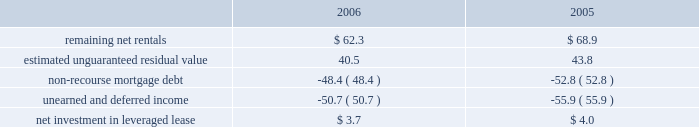Kimco realty corporation and subsidiaries job title kimco realty ar revision 6 serial date / time tuesday , april 03 , 2007 /10:32 pm job number 142704 type current page no .
65 operator pm2 <12345678> at december 31 , 2006 and 2005 , the company 2019s net invest- ment in the leveraged lease consisted of the following ( in mil- lions ) : .
Mortgages and other financing receivables : during january 2006 , the company provided approximately $ 16.0 million as its share of a $ 50.0 million junior participation in a $ 700.0 million first mortgage loan , in connection with a private investment firm 2019s acquisition of a retailer .
This loan participation bore interest at libor plus 7.75% ( 7.75 % ) per annum and had a two-year term with a one-year extension option and was collateralized by certain real estate interests of the retailer .
During june 2006 , the borrower elected to pre-pay the outstanding loan balance of approximately $ 16.0 million in full satisfaction of this loan .
Additionally , during january 2006 , the company provided approximately $ 5.2 million as its share of an $ 11.5 million term loan to a real estate developer for the acquisition of a 59 acre land parcel located in san antonio , tx .
This loan is interest only at a fixed rate of 11.0% ( 11.0 % ) for a term of two years payable monthly and collateralized by a first mortgage on the subject property .
As of december 31 , 2006 , the outstanding balance on this loan was approximately $ 5.2 million .
During february 2006 , the company committed to provide a one year $ 17.2 million credit facility at a fixed rate of 8.0% ( 8.0 % ) for a term of nine months and 9.0% ( 9.0 % ) for the remaining term to a real estate investor for the recapitalization of a discount and entertain- ment mall that it currently owns .
During 2006 , this facility was fully paid and was terminated .
During april 2006 , the company provided two separate mortgages aggregating $ 14.5 million on a property owned by a real estate investor .
Proceeds were used to payoff the existing first mortgage , buyout the existing partner and for redevelopment of the property .
The mortgages bear interest at 8.0% ( 8.0 % ) per annum and mature in 2008 and 2013 .
These mortgages are collateralized by the subject property .
As of december 31 , 2006 , the aggregate outstanding balance on these mortgages was approximately $ 15.0 million , including $ 0.5 million of accrued interest .
During may 2006 , the company provided a cad $ 23.5 million collateralized credit facility at a fixed rate of 8.5% ( 8.5 % ) per annum for a term of two years to a real estate company for the execution of its property acquisitions program .
The credit facility is guaranteed by the real estate company .
The company was issued 9811 units , valued at approximately usd $ 0.1 million , and warrants to purchase up to 0.1 million shares of the real estate company as a loan origination fee .
During august 2006 , the company increased the credit facility to cad $ 45.0 million and received an additional 9811 units , valued at approximately usd $ 0.1 million , and warrants to purchase up to 0.1 million shares of the real estate company .
As of december 31 , 2006 , the outstand- ing balance on this credit facility was approximately cad $ 3.6 million ( approximately usd $ 3.1 million ) .
During september 2005 , a newly formed joint venture , in which the company had an 80% ( 80 % ) interest , acquired a 90% ( 90 % ) interest in a $ 48.4 million mortgage receivable for a purchase price of approximately $ 34.2 million .
This loan bore interest at a rate of three-month libor plus 2.75% ( 2.75 % ) per annum and was scheduled to mature on january 12 , 2010 .
A 626-room hotel located in lake buena vista , fl collateralized the loan .
The company had determined that this joint venture entity was a vie and had further determined that the company was the primary benefici- ary of this vie and had therefore consolidated it for financial reporting purposes .
During march 2006 , the joint venture acquired the remaining 10% ( 10 % ) of this mortgage receivable for a purchase price of approximately $ 3.8 million .
During june 2006 , the joint venture accepted a pre-payment of approximately $ 45.2 million from the borrower as full satisfaction of this loan .
During august 2006 , the company provided $ 8.8 million as its share of a $ 13.2 million 12-month term loan to a retailer for general corporate purposes .
This loan bears interest at a fixed rate of 12.50% ( 12.50 % ) with interest payable monthly and a balloon payment for the principal balance at maturity .
The loan is collateralized by the underlying real estate of the retailer .
Additionally , the company funded $ 13.3 million as its share of a $ 20.0 million revolving debtor-in-possession facility to this retailer .
The facility bears interest at libor plus 3.00% ( 3.00 % ) and has an unused line fee of 0.375% ( 0.375 % ) .
This credit facility is collateralized by a first priority lien on all the retailer 2019s assets .
As of december 31 , 2006 , the compa- ny 2019s share of the outstanding balance on this loan and credit facility was approximately $ 7.6 million and $ 4.9 million , respec- tively .
During september 2006 , the company provided a mxp 57.3 million ( approximately usd $ 5.3 million ) loan to an owner of an operating property in mexico .
The loan , which is collateralized by the property , bears interest at 12.0% ( 12.0 % ) per annum and matures in 2016 .
The company is entitled to a participation feature of 25% ( 25 % ) of annual cash flows after debt service and 20% ( 20 % ) of the gain on sale of the property .
As of december 31 , 2006 , the outstand- ing balance on this loan was approximately mxp 57.8 million ( approximately usd $ 5.3 million ) .
During november 2006 , the company committed to provide a mxp 124.8 million ( approximately usd $ 11.5 million ) loan to an owner of a land parcel in acapulco , mexico .
The loan , which is collateralized with an operating property owned by the bor- rower , bears interest at 10% ( 10 % ) per annum and matures in 2016 .
The company is entitled to a participation feature of 20% ( 20 % ) of excess cash flows and gains on sale of the property .
As of decem- ber 31 , 2006 , the outstanding balance on this loan was mxp 12.8 million ( approximately usd $ 1.2 million ) . .
From 2005-2006 , what was the total amount of remaining net rentals , in millions? 
Computations: (62.3 + 68.9)
Answer: 131.2. Kimco realty corporation and subsidiaries job title kimco realty ar revision 6 serial date / time tuesday , april 03 , 2007 /10:32 pm job number 142704 type current page no .
65 operator pm2 <12345678> at december 31 , 2006 and 2005 , the company 2019s net invest- ment in the leveraged lease consisted of the following ( in mil- lions ) : .
Mortgages and other financing receivables : during january 2006 , the company provided approximately $ 16.0 million as its share of a $ 50.0 million junior participation in a $ 700.0 million first mortgage loan , in connection with a private investment firm 2019s acquisition of a retailer .
This loan participation bore interest at libor plus 7.75% ( 7.75 % ) per annum and had a two-year term with a one-year extension option and was collateralized by certain real estate interests of the retailer .
During june 2006 , the borrower elected to pre-pay the outstanding loan balance of approximately $ 16.0 million in full satisfaction of this loan .
Additionally , during january 2006 , the company provided approximately $ 5.2 million as its share of an $ 11.5 million term loan to a real estate developer for the acquisition of a 59 acre land parcel located in san antonio , tx .
This loan is interest only at a fixed rate of 11.0% ( 11.0 % ) for a term of two years payable monthly and collateralized by a first mortgage on the subject property .
As of december 31 , 2006 , the outstanding balance on this loan was approximately $ 5.2 million .
During february 2006 , the company committed to provide a one year $ 17.2 million credit facility at a fixed rate of 8.0% ( 8.0 % ) for a term of nine months and 9.0% ( 9.0 % ) for the remaining term to a real estate investor for the recapitalization of a discount and entertain- ment mall that it currently owns .
During 2006 , this facility was fully paid and was terminated .
During april 2006 , the company provided two separate mortgages aggregating $ 14.5 million on a property owned by a real estate investor .
Proceeds were used to payoff the existing first mortgage , buyout the existing partner and for redevelopment of the property .
The mortgages bear interest at 8.0% ( 8.0 % ) per annum and mature in 2008 and 2013 .
These mortgages are collateralized by the subject property .
As of december 31 , 2006 , the aggregate outstanding balance on these mortgages was approximately $ 15.0 million , including $ 0.5 million of accrued interest .
During may 2006 , the company provided a cad $ 23.5 million collateralized credit facility at a fixed rate of 8.5% ( 8.5 % ) per annum for a term of two years to a real estate company for the execution of its property acquisitions program .
The credit facility is guaranteed by the real estate company .
The company was issued 9811 units , valued at approximately usd $ 0.1 million , and warrants to purchase up to 0.1 million shares of the real estate company as a loan origination fee .
During august 2006 , the company increased the credit facility to cad $ 45.0 million and received an additional 9811 units , valued at approximately usd $ 0.1 million , and warrants to purchase up to 0.1 million shares of the real estate company .
As of december 31 , 2006 , the outstand- ing balance on this credit facility was approximately cad $ 3.6 million ( approximately usd $ 3.1 million ) .
During september 2005 , a newly formed joint venture , in which the company had an 80% ( 80 % ) interest , acquired a 90% ( 90 % ) interest in a $ 48.4 million mortgage receivable for a purchase price of approximately $ 34.2 million .
This loan bore interest at a rate of three-month libor plus 2.75% ( 2.75 % ) per annum and was scheduled to mature on january 12 , 2010 .
A 626-room hotel located in lake buena vista , fl collateralized the loan .
The company had determined that this joint venture entity was a vie and had further determined that the company was the primary benefici- ary of this vie and had therefore consolidated it for financial reporting purposes .
During march 2006 , the joint venture acquired the remaining 10% ( 10 % ) of this mortgage receivable for a purchase price of approximately $ 3.8 million .
During june 2006 , the joint venture accepted a pre-payment of approximately $ 45.2 million from the borrower as full satisfaction of this loan .
During august 2006 , the company provided $ 8.8 million as its share of a $ 13.2 million 12-month term loan to a retailer for general corporate purposes .
This loan bears interest at a fixed rate of 12.50% ( 12.50 % ) with interest payable monthly and a balloon payment for the principal balance at maturity .
The loan is collateralized by the underlying real estate of the retailer .
Additionally , the company funded $ 13.3 million as its share of a $ 20.0 million revolving debtor-in-possession facility to this retailer .
The facility bears interest at libor plus 3.00% ( 3.00 % ) and has an unused line fee of 0.375% ( 0.375 % ) .
This credit facility is collateralized by a first priority lien on all the retailer 2019s assets .
As of december 31 , 2006 , the compa- ny 2019s share of the outstanding balance on this loan and credit facility was approximately $ 7.6 million and $ 4.9 million , respec- tively .
During september 2006 , the company provided a mxp 57.3 million ( approximately usd $ 5.3 million ) loan to an owner of an operating property in mexico .
The loan , which is collateralized by the property , bears interest at 12.0% ( 12.0 % ) per annum and matures in 2016 .
The company is entitled to a participation feature of 25% ( 25 % ) of annual cash flows after debt service and 20% ( 20 % ) of the gain on sale of the property .
As of december 31 , 2006 , the outstand- ing balance on this loan was approximately mxp 57.8 million ( approximately usd $ 5.3 million ) .
During november 2006 , the company committed to provide a mxp 124.8 million ( approximately usd $ 11.5 million ) loan to an owner of a land parcel in acapulco , mexico .
The loan , which is collateralized with an operating property owned by the bor- rower , bears interest at 10% ( 10 % ) per annum and matures in 2016 .
The company is entitled to a participation feature of 20% ( 20 % ) of excess cash flows and gains on sale of the property .
As of decem- ber 31 , 2006 , the outstanding balance on this loan was mxp 12.8 million ( approximately usd $ 1.2 million ) . .
During january 2006 , what percentage of the long term loan to a real estate developer for the acquisition of a 59 acre land parcel located in san antonio , tx did the company provide? 
Computations: (5.2 / 11.5)
Answer: 0.45217. 